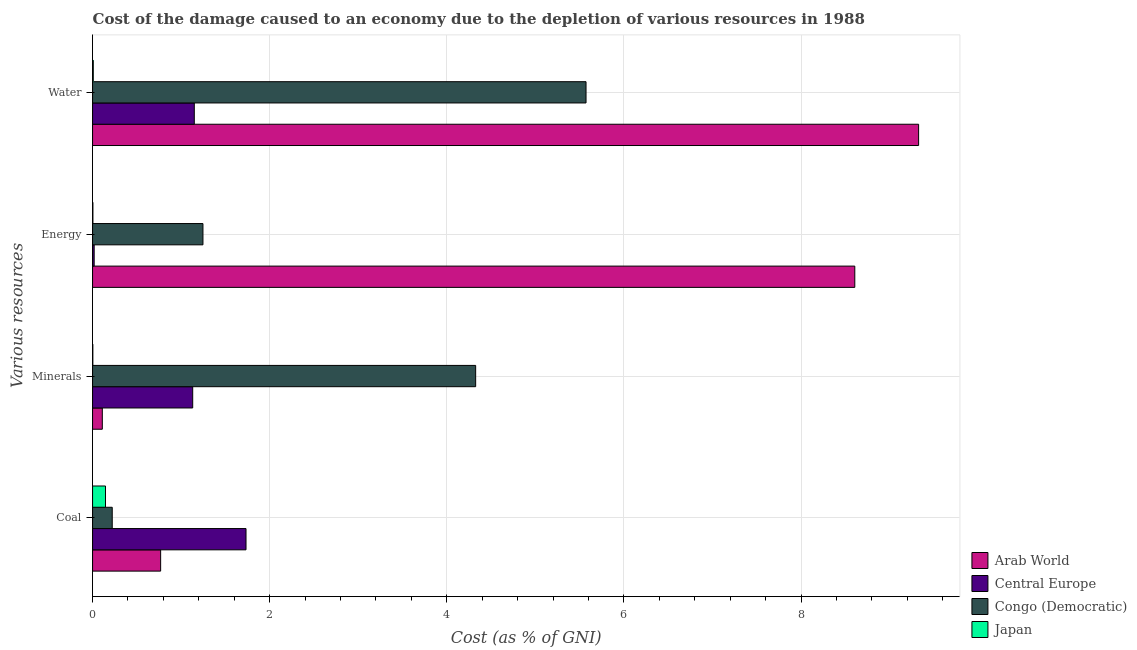Are the number of bars per tick equal to the number of legend labels?
Offer a very short reply. Yes. Are the number of bars on each tick of the Y-axis equal?
Make the answer very short. Yes. How many bars are there on the 1st tick from the top?
Your answer should be very brief. 4. How many bars are there on the 4th tick from the bottom?
Provide a short and direct response. 4. What is the label of the 4th group of bars from the top?
Offer a terse response. Coal. What is the cost of damage due to depletion of energy in Arab World?
Make the answer very short. 8.61. Across all countries, what is the maximum cost of damage due to depletion of coal?
Your answer should be very brief. 1.73. Across all countries, what is the minimum cost of damage due to depletion of coal?
Offer a terse response. 0.15. In which country was the cost of damage due to depletion of energy maximum?
Give a very brief answer. Arab World. In which country was the cost of damage due to depletion of energy minimum?
Your answer should be very brief. Japan. What is the total cost of damage due to depletion of water in the graph?
Ensure brevity in your answer.  16.06. What is the difference between the cost of damage due to depletion of minerals in Central Europe and that in Congo (Democratic)?
Give a very brief answer. -3.19. What is the difference between the cost of damage due to depletion of coal in Japan and the cost of damage due to depletion of energy in Arab World?
Ensure brevity in your answer.  -8.46. What is the average cost of damage due to depletion of minerals per country?
Offer a very short reply. 1.39. What is the difference between the cost of damage due to depletion of water and cost of damage due to depletion of minerals in Arab World?
Provide a short and direct response. 9.22. In how many countries, is the cost of damage due to depletion of minerals greater than 7.6 %?
Ensure brevity in your answer.  0. What is the ratio of the cost of damage due to depletion of water in Congo (Democratic) to that in Central Europe?
Provide a succinct answer. 4.85. Is the difference between the cost of damage due to depletion of water in Congo (Democratic) and Arab World greater than the difference between the cost of damage due to depletion of minerals in Congo (Democratic) and Arab World?
Give a very brief answer. No. What is the difference between the highest and the second highest cost of damage due to depletion of water?
Your response must be concise. 3.76. What is the difference between the highest and the lowest cost of damage due to depletion of water?
Offer a very short reply. 9.32. In how many countries, is the cost of damage due to depletion of water greater than the average cost of damage due to depletion of water taken over all countries?
Give a very brief answer. 2. Is the sum of the cost of damage due to depletion of minerals in Arab World and Congo (Democratic) greater than the maximum cost of damage due to depletion of coal across all countries?
Offer a terse response. Yes. Is it the case that in every country, the sum of the cost of damage due to depletion of water and cost of damage due to depletion of energy is greater than the sum of cost of damage due to depletion of minerals and cost of damage due to depletion of coal?
Provide a succinct answer. No. What does the 2nd bar from the bottom in Water represents?
Provide a short and direct response. Central Europe. Are all the bars in the graph horizontal?
Offer a terse response. Yes. How many countries are there in the graph?
Give a very brief answer. 4. Are the values on the major ticks of X-axis written in scientific E-notation?
Offer a very short reply. No. Does the graph contain grids?
Provide a succinct answer. Yes. Where does the legend appear in the graph?
Offer a terse response. Bottom right. How are the legend labels stacked?
Ensure brevity in your answer.  Vertical. What is the title of the graph?
Offer a very short reply. Cost of the damage caused to an economy due to the depletion of various resources in 1988 . What is the label or title of the X-axis?
Provide a short and direct response. Cost (as % of GNI). What is the label or title of the Y-axis?
Keep it short and to the point. Various resources. What is the Cost (as % of GNI) of Arab World in Coal?
Your response must be concise. 0.77. What is the Cost (as % of GNI) of Central Europe in Coal?
Give a very brief answer. 1.73. What is the Cost (as % of GNI) in Congo (Democratic) in Coal?
Ensure brevity in your answer.  0.22. What is the Cost (as % of GNI) in Japan in Coal?
Provide a short and direct response. 0.15. What is the Cost (as % of GNI) in Arab World in Minerals?
Keep it short and to the point. 0.11. What is the Cost (as % of GNI) in Central Europe in Minerals?
Ensure brevity in your answer.  1.13. What is the Cost (as % of GNI) of Congo (Democratic) in Minerals?
Your answer should be very brief. 4.33. What is the Cost (as % of GNI) in Japan in Minerals?
Your answer should be very brief. 0. What is the Cost (as % of GNI) of Arab World in Energy?
Provide a short and direct response. 8.61. What is the Cost (as % of GNI) in Central Europe in Energy?
Give a very brief answer. 0.02. What is the Cost (as % of GNI) of Congo (Democratic) in Energy?
Ensure brevity in your answer.  1.25. What is the Cost (as % of GNI) in Japan in Energy?
Offer a terse response. 0. What is the Cost (as % of GNI) in Arab World in Water?
Provide a short and direct response. 9.33. What is the Cost (as % of GNI) of Central Europe in Water?
Provide a succinct answer. 1.15. What is the Cost (as % of GNI) of Congo (Democratic) in Water?
Your response must be concise. 5.57. What is the Cost (as % of GNI) in Japan in Water?
Ensure brevity in your answer.  0.01. Across all Various resources, what is the maximum Cost (as % of GNI) of Arab World?
Provide a short and direct response. 9.33. Across all Various resources, what is the maximum Cost (as % of GNI) of Central Europe?
Provide a succinct answer. 1.73. Across all Various resources, what is the maximum Cost (as % of GNI) in Congo (Democratic)?
Provide a short and direct response. 5.57. Across all Various resources, what is the maximum Cost (as % of GNI) of Japan?
Your response must be concise. 0.15. Across all Various resources, what is the minimum Cost (as % of GNI) in Arab World?
Offer a very short reply. 0.11. Across all Various resources, what is the minimum Cost (as % of GNI) of Central Europe?
Keep it short and to the point. 0.02. Across all Various resources, what is the minimum Cost (as % of GNI) of Congo (Democratic)?
Provide a short and direct response. 0.22. Across all Various resources, what is the minimum Cost (as % of GNI) in Japan?
Make the answer very short. 0. What is the total Cost (as % of GNI) of Arab World in the graph?
Provide a succinct answer. 18.81. What is the total Cost (as % of GNI) in Central Europe in the graph?
Offer a terse response. 4.03. What is the total Cost (as % of GNI) of Congo (Democratic) in the graph?
Keep it short and to the point. 11.37. What is the total Cost (as % of GNI) of Japan in the graph?
Offer a terse response. 0.16. What is the difference between the Cost (as % of GNI) in Arab World in Coal and that in Minerals?
Your response must be concise. 0.66. What is the difference between the Cost (as % of GNI) in Central Europe in Coal and that in Minerals?
Your response must be concise. 0.6. What is the difference between the Cost (as % of GNI) of Congo (Democratic) in Coal and that in Minerals?
Provide a short and direct response. -4.1. What is the difference between the Cost (as % of GNI) of Japan in Coal and that in Minerals?
Provide a succinct answer. 0.14. What is the difference between the Cost (as % of GNI) of Arab World in Coal and that in Energy?
Ensure brevity in your answer.  -7.84. What is the difference between the Cost (as % of GNI) of Central Europe in Coal and that in Energy?
Provide a succinct answer. 1.71. What is the difference between the Cost (as % of GNI) of Congo (Democratic) in Coal and that in Energy?
Keep it short and to the point. -1.02. What is the difference between the Cost (as % of GNI) of Japan in Coal and that in Energy?
Make the answer very short. 0.14. What is the difference between the Cost (as % of GNI) of Arab World in Coal and that in Water?
Offer a very short reply. -8.56. What is the difference between the Cost (as % of GNI) of Central Europe in Coal and that in Water?
Ensure brevity in your answer.  0.58. What is the difference between the Cost (as % of GNI) in Congo (Democratic) in Coal and that in Water?
Offer a very short reply. -5.35. What is the difference between the Cost (as % of GNI) of Japan in Coal and that in Water?
Provide a succinct answer. 0.14. What is the difference between the Cost (as % of GNI) of Arab World in Minerals and that in Energy?
Your response must be concise. -8.5. What is the difference between the Cost (as % of GNI) of Central Europe in Minerals and that in Energy?
Make the answer very short. 1.11. What is the difference between the Cost (as % of GNI) in Congo (Democratic) in Minerals and that in Energy?
Provide a succinct answer. 3.08. What is the difference between the Cost (as % of GNI) in Japan in Minerals and that in Energy?
Offer a terse response. -0. What is the difference between the Cost (as % of GNI) in Arab World in Minerals and that in Water?
Your answer should be compact. -9.22. What is the difference between the Cost (as % of GNI) in Central Europe in Minerals and that in Water?
Ensure brevity in your answer.  -0.02. What is the difference between the Cost (as % of GNI) in Congo (Democratic) in Minerals and that in Water?
Offer a terse response. -1.25. What is the difference between the Cost (as % of GNI) of Japan in Minerals and that in Water?
Ensure brevity in your answer.  -0.01. What is the difference between the Cost (as % of GNI) of Arab World in Energy and that in Water?
Give a very brief answer. -0.72. What is the difference between the Cost (as % of GNI) of Central Europe in Energy and that in Water?
Your response must be concise. -1.13. What is the difference between the Cost (as % of GNI) in Congo (Democratic) in Energy and that in Water?
Give a very brief answer. -4.33. What is the difference between the Cost (as % of GNI) in Japan in Energy and that in Water?
Provide a short and direct response. -0. What is the difference between the Cost (as % of GNI) in Arab World in Coal and the Cost (as % of GNI) in Central Europe in Minerals?
Give a very brief answer. -0.36. What is the difference between the Cost (as % of GNI) in Arab World in Coal and the Cost (as % of GNI) in Congo (Democratic) in Minerals?
Provide a succinct answer. -3.56. What is the difference between the Cost (as % of GNI) of Arab World in Coal and the Cost (as % of GNI) of Japan in Minerals?
Your answer should be very brief. 0.77. What is the difference between the Cost (as % of GNI) in Central Europe in Coal and the Cost (as % of GNI) in Congo (Democratic) in Minerals?
Offer a very short reply. -2.59. What is the difference between the Cost (as % of GNI) of Central Europe in Coal and the Cost (as % of GNI) of Japan in Minerals?
Your answer should be very brief. 1.73. What is the difference between the Cost (as % of GNI) of Congo (Democratic) in Coal and the Cost (as % of GNI) of Japan in Minerals?
Your answer should be compact. 0.22. What is the difference between the Cost (as % of GNI) of Arab World in Coal and the Cost (as % of GNI) of Central Europe in Energy?
Offer a terse response. 0.75. What is the difference between the Cost (as % of GNI) in Arab World in Coal and the Cost (as % of GNI) in Congo (Democratic) in Energy?
Provide a short and direct response. -0.48. What is the difference between the Cost (as % of GNI) in Arab World in Coal and the Cost (as % of GNI) in Japan in Energy?
Provide a short and direct response. 0.76. What is the difference between the Cost (as % of GNI) in Central Europe in Coal and the Cost (as % of GNI) in Congo (Democratic) in Energy?
Your answer should be compact. 0.49. What is the difference between the Cost (as % of GNI) of Central Europe in Coal and the Cost (as % of GNI) of Japan in Energy?
Your response must be concise. 1.73. What is the difference between the Cost (as % of GNI) of Congo (Democratic) in Coal and the Cost (as % of GNI) of Japan in Energy?
Give a very brief answer. 0.22. What is the difference between the Cost (as % of GNI) of Arab World in Coal and the Cost (as % of GNI) of Central Europe in Water?
Your answer should be compact. -0.38. What is the difference between the Cost (as % of GNI) of Arab World in Coal and the Cost (as % of GNI) of Congo (Democratic) in Water?
Give a very brief answer. -4.8. What is the difference between the Cost (as % of GNI) of Arab World in Coal and the Cost (as % of GNI) of Japan in Water?
Ensure brevity in your answer.  0.76. What is the difference between the Cost (as % of GNI) in Central Europe in Coal and the Cost (as % of GNI) in Congo (Democratic) in Water?
Provide a short and direct response. -3.84. What is the difference between the Cost (as % of GNI) in Central Europe in Coal and the Cost (as % of GNI) in Japan in Water?
Provide a short and direct response. 1.72. What is the difference between the Cost (as % of GNI) in Congo (Democratic) in Coal and the Cost (as % of GNI) in Japan in Water?
Offer a terse response. 0.21. What is the difference between the Cost (as % of GNI) of Arab World in Minerals and the Cost (as % of GNI) of Central Europe in Energy?
Your answer should be very brief. 0.09. What is the difference between the Cost (as % of GNI) in Arab World in Minerals and the Cost (as % of GNI) in Congo (Democratic) in Energy?
Give a very brief answer. -1.14. What is the difference between the Cost (as % of GNI) in Arab World in Minerals and the Cost (as % of GNI) in Japan in Energy?
Provide a short and direct response. 0.11. What is the difference between the Cost (as % of GNI) in Central Europe in Minerals and the Cost (as % of GNI) in Congo (Democratic) in Energy?
Offer a very short reply. -0.12. What is the difference between the Cost (as % of GNI) of Central Europe in Minerals and the Cost (as % of GNI) of Japan in Energy?
Your answer should be very brief. 1.13. What is the difference between the Cost (as % of GNI) of Congo (Democratic) in Minerals and the Cost (as % of GNI) of Japan in Energy?
Provide a short and direct response. 4.32. What is the difference between the Cost (as % of GNI) in Arab World in Minerals and the Cost (as % of GNI) in Central Europe in Water?
Your answer should be very brief. -1.04. What is the difference between the Cost (as % of GNI) of Arab World in Minerals and the Cost (as % of GNI) of Congo (Democratic) in Water?
Ensure brevity in your answer.  -5.46. What is the difference between the Cost (as % of GNI) of Arab World in Minerals and the Cost (as % of GNI) of Japan in Water?
Make the answer very short. 0.1. What is the difference between the Cost (as % of GNI) of Central Europe in Minerals and the Cost (as % of GNI) of Congo (Democratic) in Water?
Make the answer very short. -4.44. What is the difference between the Cost (as % of GNI) of Central Europe in Minerals and the Cost (as % of GNI) of Japan in Water?
Ensure brevity in your answer.  1.12. What is the difference between the Cost (as % of GNI) of Congo (Democratic) in Minerals and the Cost (as % of GNI) of Japan in Water?
Keep it short and to the point. 4.32. What is the difference between the Cost (as % of GNI) in Arab World in Energy and the Cost (as % of GNI) in Central Europe in Water?
Offer a terse response. 7.46. What is the difference between the Cost (as % of GNI) in Arab World in Energy and the Cost (as % of GNI) in Congo (Democratic) in Water?
Provide a short and direct response. 3.03. What is the difference between the Cost (as % of GNI) in Arab World in Energy and the Cost (as % of GNI) in Japan in Water?
Your response must be concise. 8.6. What is the difference between the Cost (as % of GNI) of Central Europe in Energy and the Cost (as % of GNI) of Congo (Democratic) in Water?
Your response must be concise. -5.55. What is the difference between the Cost (as % of GNI) in Central Europe in Energy and the Cost (as % of GNI) in Japan in Water?
Your response must be concise. 0.01. What is the difference between the Cost (as % of GNI) of Congo (Democratic) in Energy and the Cost (as % of GNI) of Japan in Water?
Provide a succinct answer. 1.24. What is the average Cost (as % of GNI) of Arab World per Various resources?
Your answer should be very brief. 4.7. What is the average Cost (as % of GNI) of Central Europe per Various resources?
Give a very brief answer. 1.01. What is the average Cost (as % of GNI) of Congo (Democratic) per Various resources?
Your answer should be compact. 2.84. What is the average Cost (as % of GNI) in Japan per Various resources?
Offer a terse response. 0.04. What is the difference between the Cost (as % of GNI) of Arab World and Cost (as % of GNI) of Central Europe in Coal?
Give a very brief answer. -0.96. What is the difference between the Cost (as % of GNI) in Arab World and Cost (as % of GNI) in Congo (Democratic) in Coal?
Keep it short and to the point. 0.55. What is the difference between the Cost (as % of GNI) in Arab World and Cost (as % of GNI) in Japan in Coal?
Your answer should be very brief. 0.62. What is the difference between the Cost (as % of GNI) of Central Europe and Cost (as % of GNI) of Congo (Democratic) in Coal?
Offer a terse response. 1.51. What is the difference between the Cost (as % of GNI) of Central Europe and Cost (as % of GNI) of Japan in Coal?
Offer a terse response. 1.59. What is the difference between the Cost (as % of GNI) in Congo (Democratic) and Cost (as % of GNI) in Japan in Coal?
Give a very brief answer. 0.08. What is the difference between the Cost (as % of GNI) of Arab World and Cost (as % of GNI) of Central Europe in Minerals?
Provide a succinct answer. -1.02. What is the difference between the Cost (as % of GNI) in Arab World and Cost (as % of GNI) in Congo (Democratic) in Minerals?
Your response must be concise. -4.22. What is the difference between the Cost (as % of GNI) of Arab World and Cost (as % of GNI) of Japan in Minerals?
Give a very brief answer. 0.11. What is the difference between the Cost (as % of GNI) of Central Europe and Cost (as % of GNI) of Congo (Democratic) in Minerals?
Offer a very short reply. -3.19. What is the difference between the Cost (as % of GNI) in Central Europe and Cost (as % of GNI) in Japan in Minerals?
Your answer should be very brief. 1.13. What is the difference between the Cost (as % of GNI) of Congo (Democratic) and Cost (as % of GNI) of Japan in Minerals?
Ensure brevity in your answer.  4.32. What is the difference between the Cost (as % of GNI) in Arab World and Cost (as % of GNI) in Central Europe in Energy?
Your response must be concise. 8.59. What is the difference between the Cost (as % of GNI) of Arab World and Cost (as % of GNI) of Congo (Democratic) in Energy?
Provide a succinct answer. 7.36. What is the difference between the Cost (as % of GNI) of Arab World and Cost (as % of GNI) of Japan in Energy?
Keep it short and to the point. 8.6. What is the difference between the Cost (as % of GNI) in Central Europe and Cost (as % of GNI) in Congo (Democratic) in Energy?
Your response must be concise. -1.23. What is the difference between the Cost (as % of GNI) of Central Europe and Cost (as % of GNI) of Japan in Energy?
Your answer should be compact. 0.01. What is the difference between the Cost (as % of GNI) of Congo (Democratic) and Cost (as % of GNI) of Japan in Energy?
Your answer should be compact. 1.24. What is the difference between the Cost (as % of GNI) in Arab World and Cost (as % of GNI) in Central Europe in Water?
Offer a very short reply. 8.18. What is the difference between the Cost (as % of GNI) of Arab World and Cost (as % of GNI) of Congo (Democratic) in Water?
Your response must be concise. 3.76. What is the difference between the Cost (as % of GNI) of Arab World and Cost (as % of GNI) of Japan in Water?
Offer a terse response. 9.32. What is the difference between the Cost (as % of GNI) of Central Europe and Cost (as % of GNI) of Congo (Democratic) in Water?
Your answer should be very brief. -4.42. What is the difference between the Cost (as % of GNI) in Central Europe and Cost (as % of GNI) in Japan in Water?
Your answer should be compact. 1.14. What is the difference between the Cost (as % of GNI) in Congo (Democratic) and Cost (as % of GNI) in Japan in Water?
Provide a short and direct response. 5.56. What is the ratio of the Cost (as % of GNI) of Arab World in Coal to that in Minerals?
Give a very brief answer. 6.98. What is the ratio of the Cost (as % of GNI) in Central Europe in Coal to that in Minerals?
Your answer should be compact. 1.53. What is the ratio of the Cost (as % of GNI) of Congo (Democratic) in Coal to that in Minerals?
Your response must be concise. 0.05. What is the ratio of the Cost (as % of GNI) in Japan in Coal to that in Minerals?
Provide a succinct answer. 46.99. What is the ratio of the Cost (as % of GNI) of Arab World in Coal to that in Energy?
Provide a succinct answer. 0.09. What is the ratio of the Cost (as % of GNI) in Central Europe in Coal to that in Energy?
Your answer should be compact. 95.97. What is the ratio of the Cost (as % of GNI) in Congo (Democratic) in Coal to that in Energy?
Provide a succinct answer. 0.18. What is the ratio of the Cost (as % of GNI) in Japan in Coal to that in Energy?
Provide a succinct answer. 37.47. What is the ratio of the Cost (as % of GNI) of Arab World in Coal to that in Water?
Provide a short and direct response. 0.08. What is the ratio of the Cost (as % of GNI) of Central Europe in Coal to that in Water?
Give a very brief answer. 1.51. What is the ratio of the Cost (as % of GNI) in Congo (Democratic) in Coal to that in Water?
Ensure brevity in your answer.  0.04. What is the ratio of the Cost (as % of GNI) in Japan in Coal to that in Water?
Your response must be concise. 18. What is the ratio of the Cost (as % of GNI) of Arab World in Minerals to that in Energy?
Make the answer very short. 0.01. What is the ratio of the Cost (as % of GNI) of Central Europe in Minerals to that in Energy?
Give a very brief answer. 62.62. What is the ratio of the Cost (as % of GNI) in Congo (Democratic) in Minerals to that in Energy?
Your answer should be compact. 3.47. What is the ratio of the Cost (as % of GNI) in Japan in Minerals to that in Energy?
Offer a very short reply. 0.8. What is the ratio of the Cost (as % of GNI) in Arab World in Minerals to that in Water?
Give a very brief answer. 0.01. What is the ratio of the Cost (as % of GNI) in Central Europe in Minerals to that in Water?
Your answer should be very brief. 0.98. What is the ratio of the Cost (as % of GNI) of Congo (Democratic) in Minerals to that in Water?
Keep it short and to the point. 0.78. What is the ratio of the Cost (as % of GNI) of Japan in Minerals to that in Water?
Make the answer very short. 0.38. What is the ratio of the Cost (as % of GNI) of Arab World in Energy to that in Water?
Your response must be concise. 0.92. What is the ratio of the Cost (as % of GNI) in Central Europe in Energy to that in Water?
Ensure brevity in your answer.  0.02. What is the ratio of the Cost (as % of GNI) in Congo (Democratic) in Energy to that in Water?
Make the answer very short. 0.22. What is the ratio of the Cost (as % of GNI) in Japan in Energy to that in Water?
Give a very brief answer. 0.48. What is the difference between the highest and the second highest Cost (as % of GNI) of Arab World?
Ensure brevity in your answer.  0.72. What is the difference between the highest and the second highest Cost (as % of GNI) in Central Europe?
Provide a short and direct response. 0.58. What is the difference between the highest and the second highest Cost (as % of GNI) in Congo (Democratic)?
Provide a short and direct response. 1.25. What is the difference between the highest and the second highest Cost (as % of GNI) of Japan?
Keep it short and to the point. 0.14. What is the difference between the highest and the lowest Cost (as % of GNI) of Arab World?
Offer a very short reply. 9.22. What is the difference between the highest and the lowest Cost (as % of GNI) in Central Europe?
Offer a very short reply. 1.71. What is the difference between the highest and the lowest Cost (as % of GNI) in Congo (Democratic)?
Your response must be concise. 5.35. What is the difference between the highest and the lowest Cost (as % of GNI) of Japan?
Offer a very short reply. 0.14. 